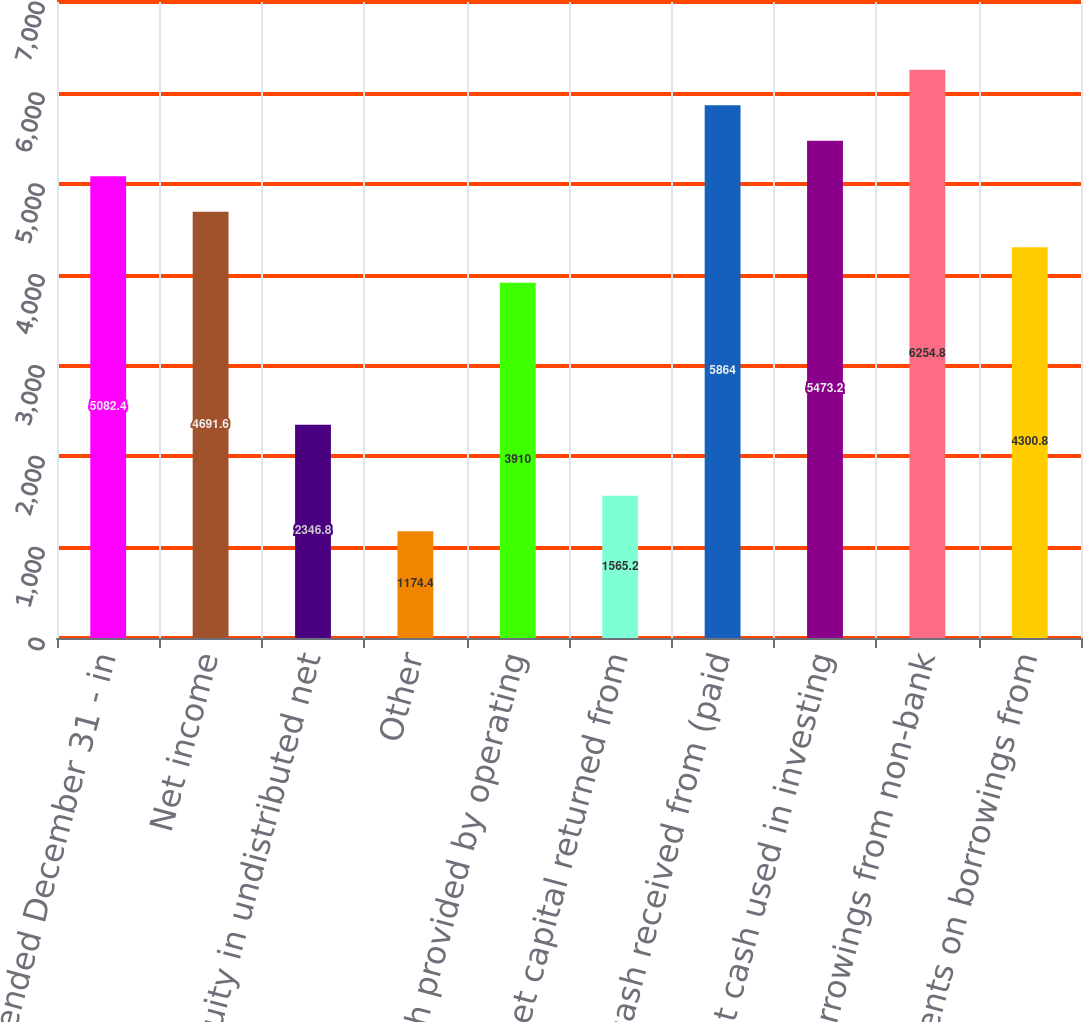Convert chart to OTSL. <chart><loc_0><loc_0><loc_500><loc_500><bar_chart><fcel>Year ended December 31 - in<fcel>Net income<fcel>Equity in undistributed net<fcel>Other<fcel>Net cash provided by operating<fcel>Net capital returned from<fcel>Net cash received from (paid<fcel>Net cash used in investing<fcel>Borrowings from non-bank<fcel>Repayments on borrowings from<nl><fcel>5082.4<fcel>4691.6<fcel>2346.8<fcel>1174.4<fcel>3910<fcel>1565.2<fcel>5864<fcel>5473.2<fcel>6254.8<fcel>4300.8<nl></chart> 